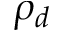<formula> <loc_0><loc_0><loc_500><loc_500>\rho _ { d }</formula> 